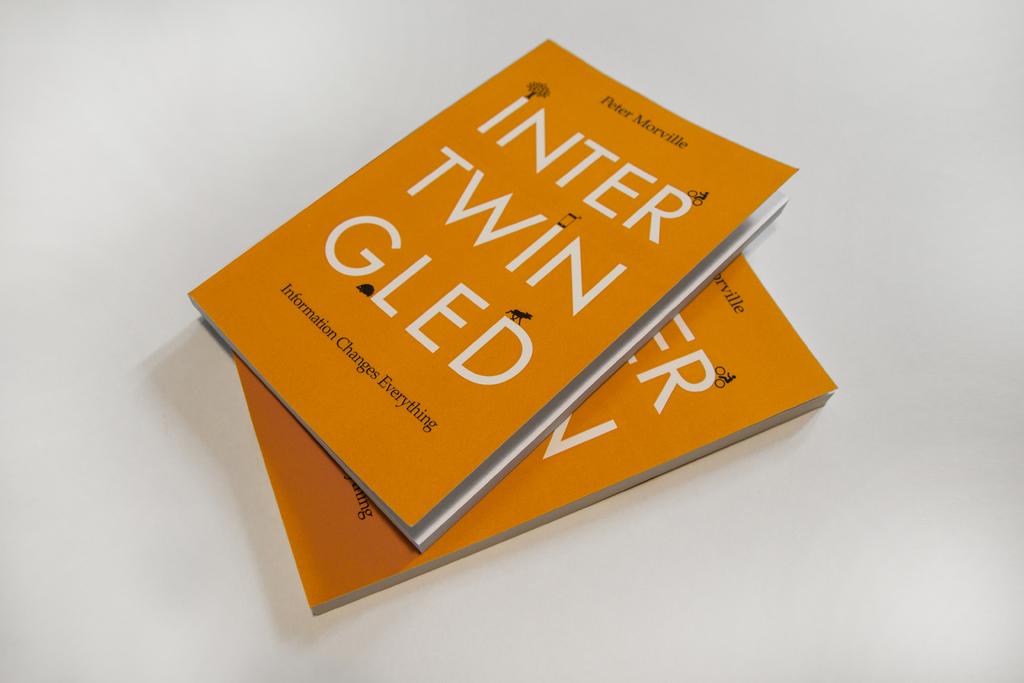Is this by peter morville?
Your answer should be compact. Yes. What is the title of the book?
Provide a short and direct response. Intertwingled. 